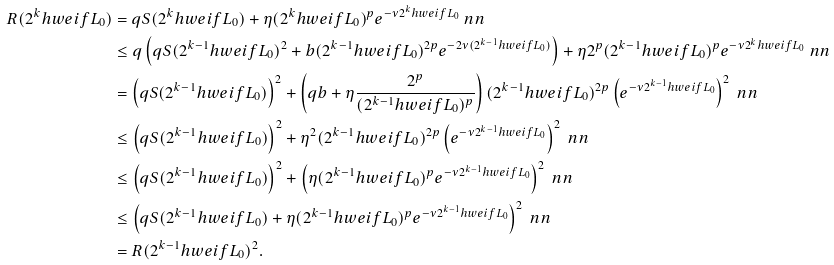<formula> <loc_0><loc_0><loc_500><loc_500>R ( 2 ^ { k } h w e i f { L } _ { 0 } ) & = q S ( 2 ^ { k } h w e i f { L } _ { 0 } ) + \eta ( 2 ^ { k } h w e i f { L } _ { 0 } ) ^ { p } e ^ { - \nu 2 ^ { k } h w e i f { L } _ { 0 } } \ n n \\ & \leq q \left ( q S ( 2 ^ { k - 1 } h w e i f { L } _ { 0 } ) ^ { 2 } + b ( 2 ^ { k - 1 } h w e i f { L } _ { 0 } ) ^ { 2 p } e ^ { - 2 \nu ( 2 ^ { k - 1 } h w e i f { L } _ { 0 } ) } \right ) + \eta 2 ^ { p } ( 2 ^ { k - 1 } h w e i f { L } _ { 0 } ) ^ { p } e ^ { - \nu 2 ^ { k } h w e i f { L } _ { 0 } } \ n n \\ & = \left ( q S ( 2 ^ { k - 1 } h w e i f { L } _ { 0 } ) \right ) ^ { 2 } + \left ( q b + \eta \frac { 2 ^ { p } } { ( 2 ^ { k - 1 } h w e i f { L } _ { 0 } ) ^ { p } } \right ) ( 2 ^ { k - 1 } h w e i f { L } _ { 0 } ) ^ { 2 p } \left ( e ^ { - \nu 2 ^ { k - 1 } h w e i f { L } _ { 0 } } \right ) ^ { 2 } \ n n \\ & \leq \left ( q S ( 2 ^ { k - 1 } h w e i f { L } _ { 0 } ) \right ) ^ { 2 } + \eta ^ { 2 } ( 2 ^ { k - 1 } h w e i f { L } _ { 0 } ) ^ { 2 p } \left ( e ^ { - \nu 2 ^ { k - 1 } h w e i f { L } _ { 0 } } \right ) ^ { 2 } \ n n \\ & \leq \left ( q S ( 2 ^ { k - 1 } h w e i f { L } _ { 0 } ) \right ) ^ { 2 } + \left ( \eta ( 2 ^ { k - 1 } h w e i f { L } _ { 0 } ) ^ { p } e ^ { - \nu 2 ^ { k - 1 } h w e i f { L } _ { 0 } } \right ) ^ { 2 } \ n n \\ & \leq \left ( q S ( 2 ^ { k - 1 } h w e i f { L } _ { 0 } ) + \eta ( 2 ^ { k - 1 } h w e i f { L } _ { 0 } ) ^ { p } e ^ { - \nu 2 ^ { k - 1 } h w e i f { L } _ { 0 } } \right ) ^ { 2 } \ n n \\ & = R ( 2 ^ { k - 1 } h w e i f { L } _ { 0 } ) ^ { 2 } .</formula> 